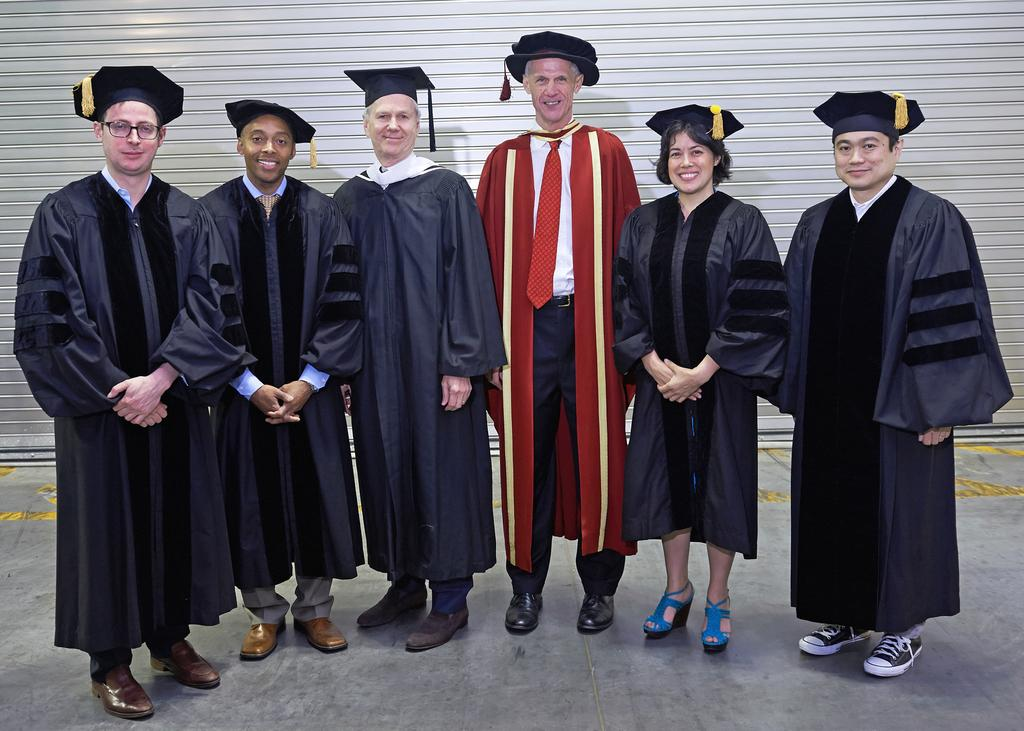How many persons are in the image? There are persons in the image. What can be observed about the coats the persons are wearing? The persons are wearing different colored coats. What is the facial expression of the persons in the image? The persons are smiling. Where are the persons standing in the image? The persons are standing on the floor. What can be seen in the background of the image? There is a wall in the background of the image, and the background color is gray. What type of juice can be seen dripping from the corn in the image? There is no juice or corn present in the image. Is there a cobweb visible on the wall in the background of the image? There is no mention of a cobweb in the provided facts, so we cannot determine its presence from the image. 